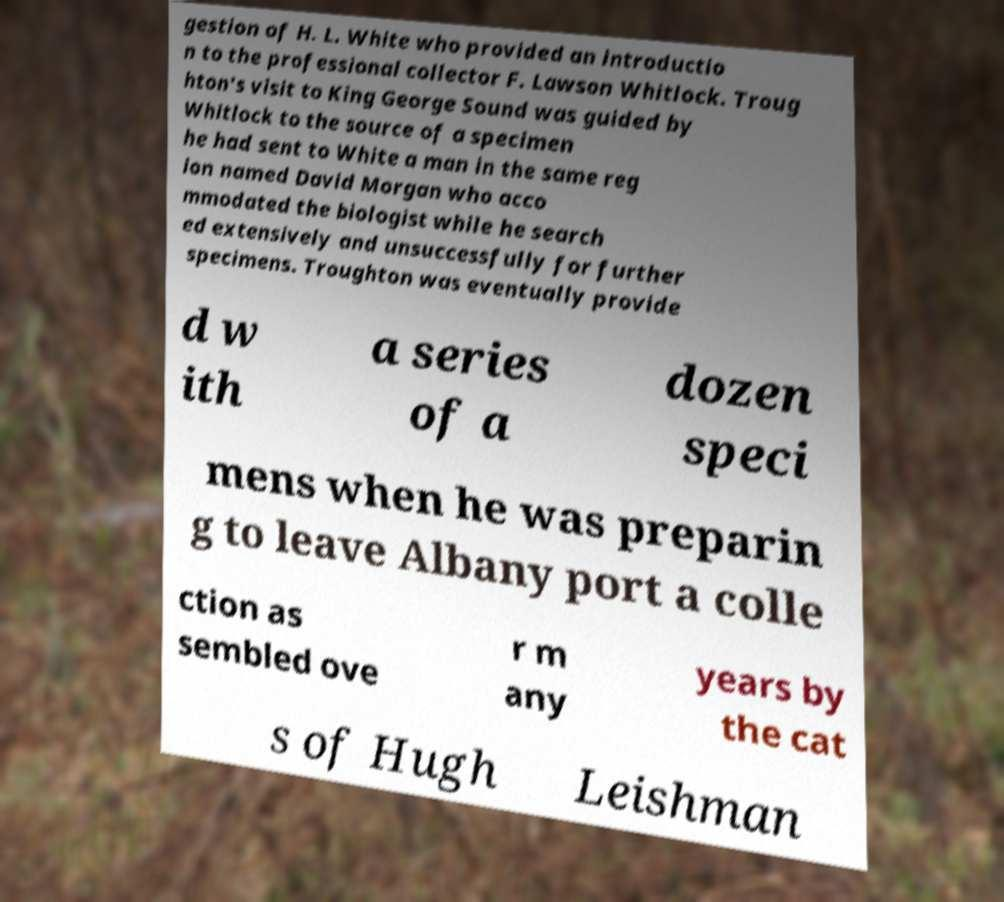For documentation purposes, I need the text within this image transcribed. Could you provide that? gestion of H. L. White who provided an introductio n to the professional collector F. Lawson Whitlock. Troug hton's visit to King George Sound was guided by Whitlock to the source of a specimen he had sent to White a man in the same reg ion named David Morgan who acco mmodated the biologist while he search ed extensively and unsuccessfully for further specimens. Troughton was eventually provide d w ith a series of a dozen speci mens when he was preparin g to leave Albany port a colle ction as sembled ove r m any years by the cat s of Hugh Leishman 